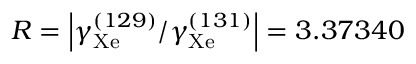Convert formula to latex. <formula><loc_0><loc_0><loc_500><loc_500>R = \left | \gamma _ { X e } ^ { ( 1 2 9 ) } / \gamma _ { X e } ^ { ( 1 3 1 ) } \right | = 3 . 3 7 3 4 0</formula> 